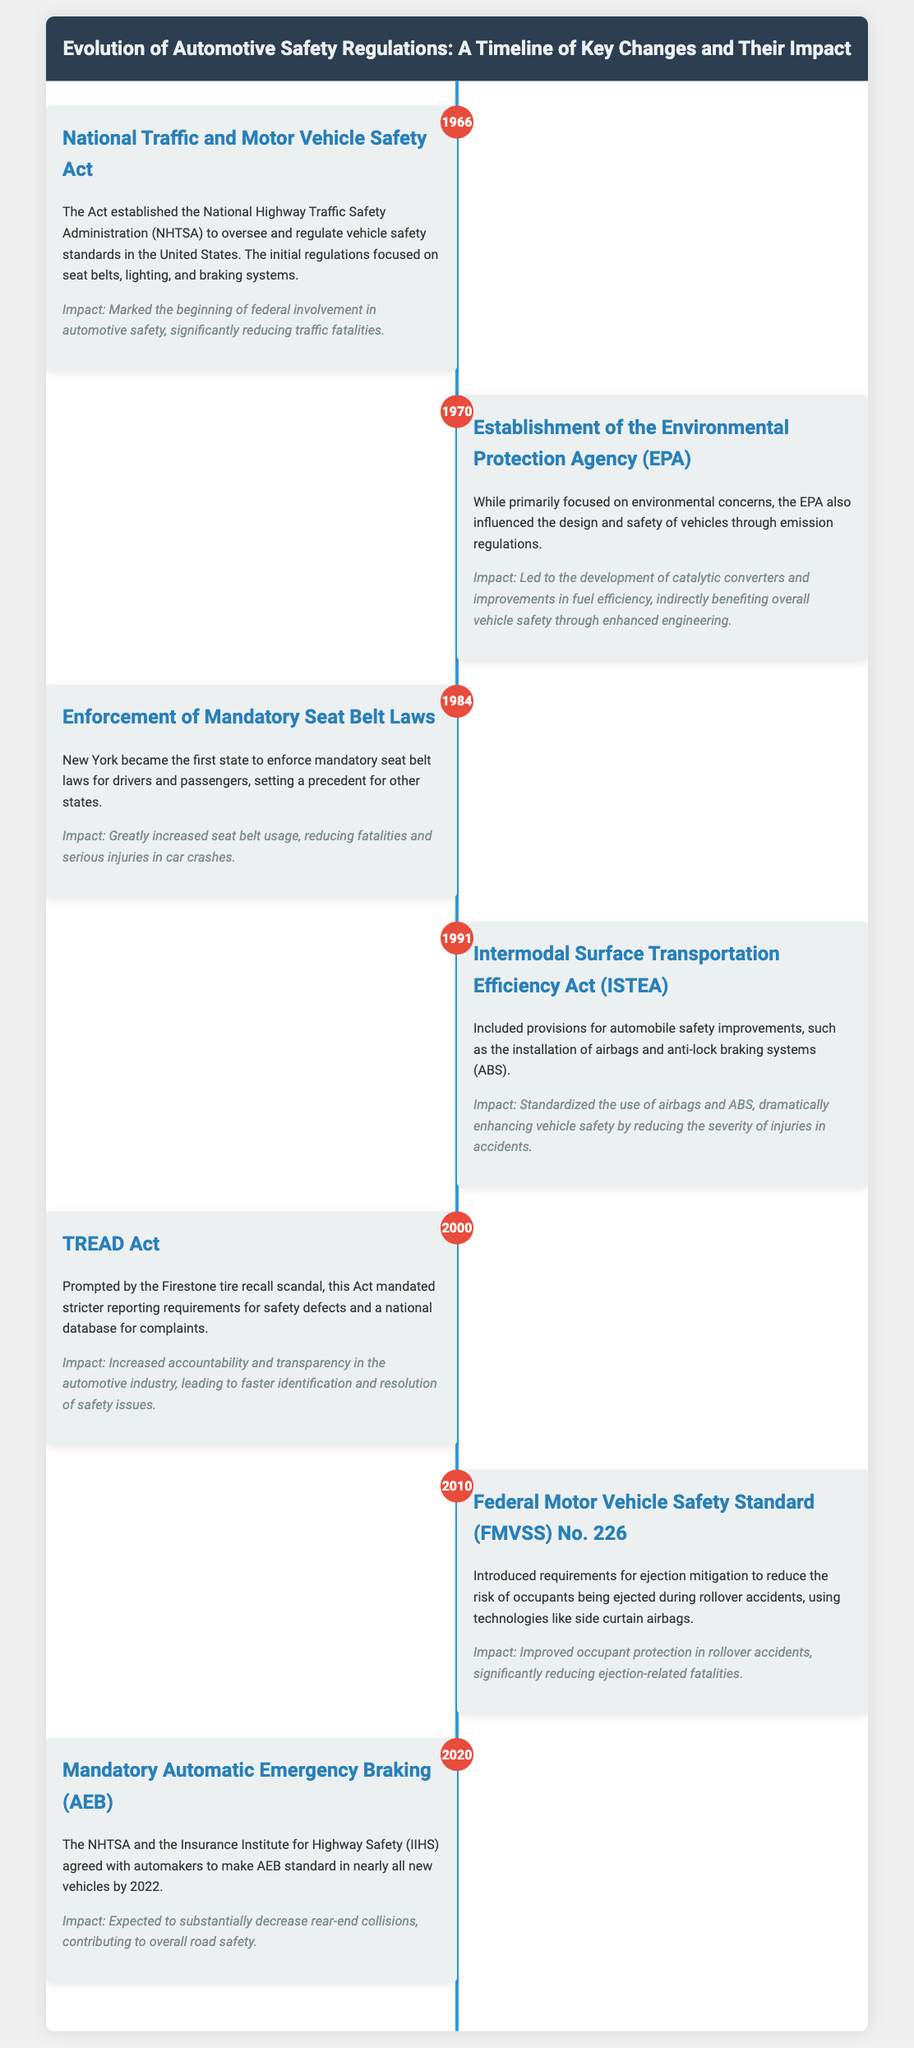What year was the National Traffic and Motor Vehicle Safety Act established? The document states that the National Traffic and Motor Vehicle Safety Act was established in 1966.
Answer: 1966 What was the primary focus of the Environmental Protection Agency (EPA) in 1970? According to the document, the EPA's primary focus was on environmental concerns, which also influenced vehicle design and safety through emission regulations.
Answer: Environmental concerns What state enforced mandatory seat belt laws first in 1984? The document indicates that New York became the first state to enforce mandatory seat belt laws for drivers and passengers.
Answer: New York What safety feature was standardized by the Intermodal Surface Transportation Efficiency Act in 1991? The document mentions that the Act standardized the use of airbags and anti-lock braking systems (ABS).
Answer: Airbags and ABS What was the impact of the TREAD Act implemented in 2000? The document explains that the TREAD Act increased accountability and transparency in the automotive industry related to safety defects and complaints.
Answer: Increased accountability What requirement was introduced by FMVSS No. 226 in 2010? The document states that FMVSS No. 226 introduced requirements for ejection mitigation during rollover accidents.
Answer: Ejection mitigation What is the expected impact of mandatory Automatic Emergency Braking by 2022? According to the document, the expected impact is a substantial decrease in rear-end collisions.
Answer: Decrease in rear-end collisions Which two organizations agreed on making Automatic Emergency Braking standard in 2020? The document identifies the NHTSA and the Insurance Institute for Highway Safety (IIHS) as the two organizations involved.
Answer: NHTSA and IIHS 